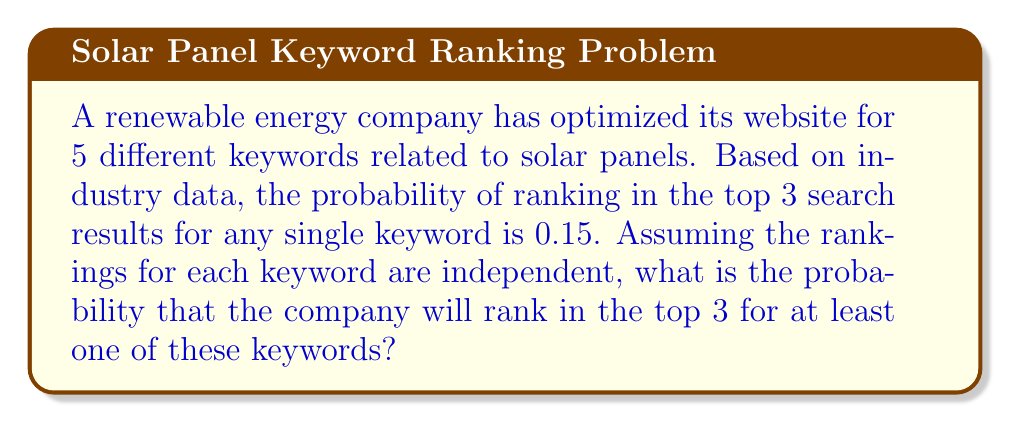Could you help me with this problem? Let's approach this step-by-step:

1) First, let's define our events:
   Let A be the event "ranking in the top 3 for a single keyword"
   P(A) = 0.15

2) We want to find the probability of ranking in the top 3 for at least one out of 5 keywords. It's easier to calculate the probability of the complement event: not ranking in the top 3 for any of the 5 keywords.

3) The probability of not ranking in the top 3 for a single keyword is:
   P(not A) = 1 - P(A) = 1 - 0.15 = 0.85

4) Since the rankings are independent, we can use the multiplication rule. The probability of not ranking in the top 3 for all 5 keywords is:
   P(not A for all 5) = $(0.85)^5$

5) Now, the probability of ranking in the top 3 for at least one keyword is the complement of this:
   P(at least one) = 1 - P(not A for all 5)
                   = $1 - (0.85)^5$

6) Let's calculate this:
   $1 - (0.85)^5 = 1 - 0.4437 = 0.5563$

Therefore, the probability of ranking in the top 3 for at least one of the 5 keywords is approximately 0.5563 or 55.63%.
Answer: 0.5563 